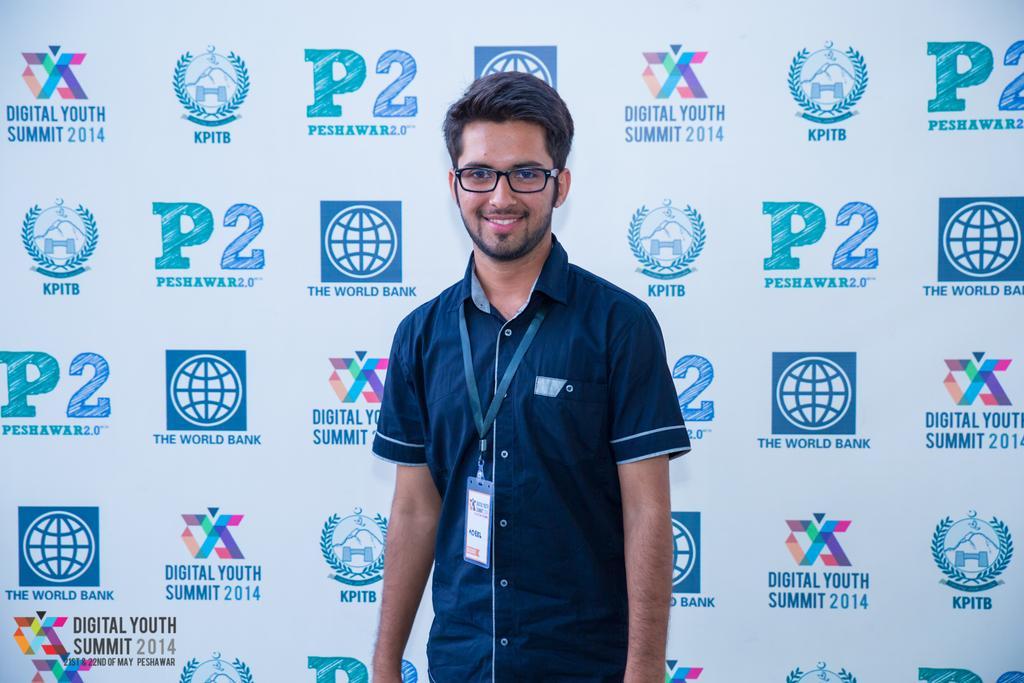Can you describe this image briefly? In the center of the image we can see a man standing and smiling. He is wearing glasses. In the background there is a board. 